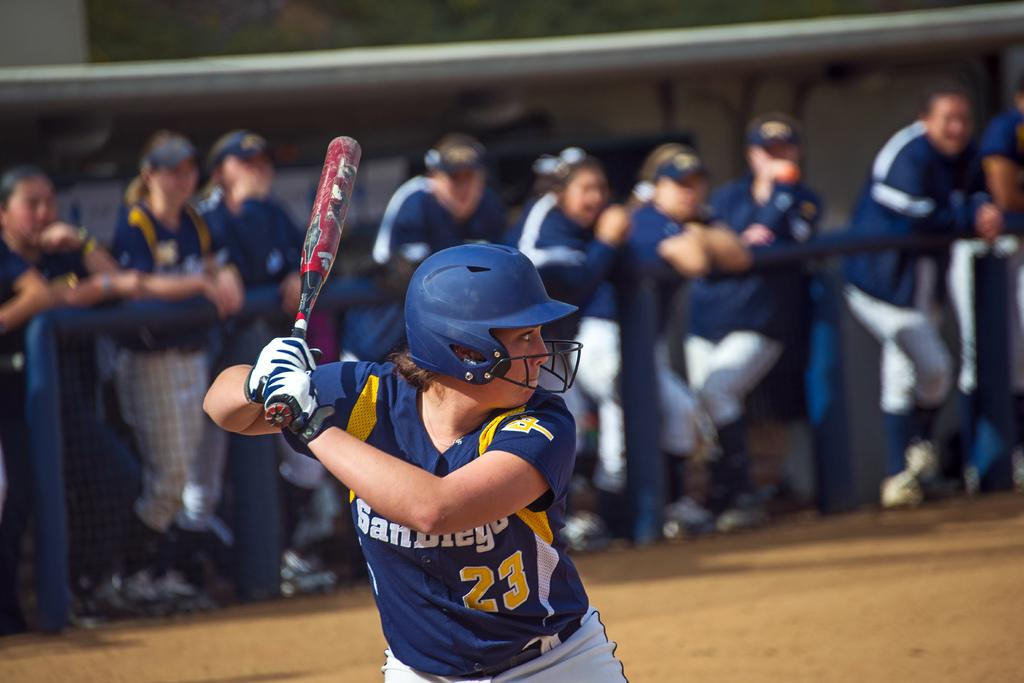<image>
Render a clear and concise summary of the photo. a person getting ready to hit a ball with the number 23 